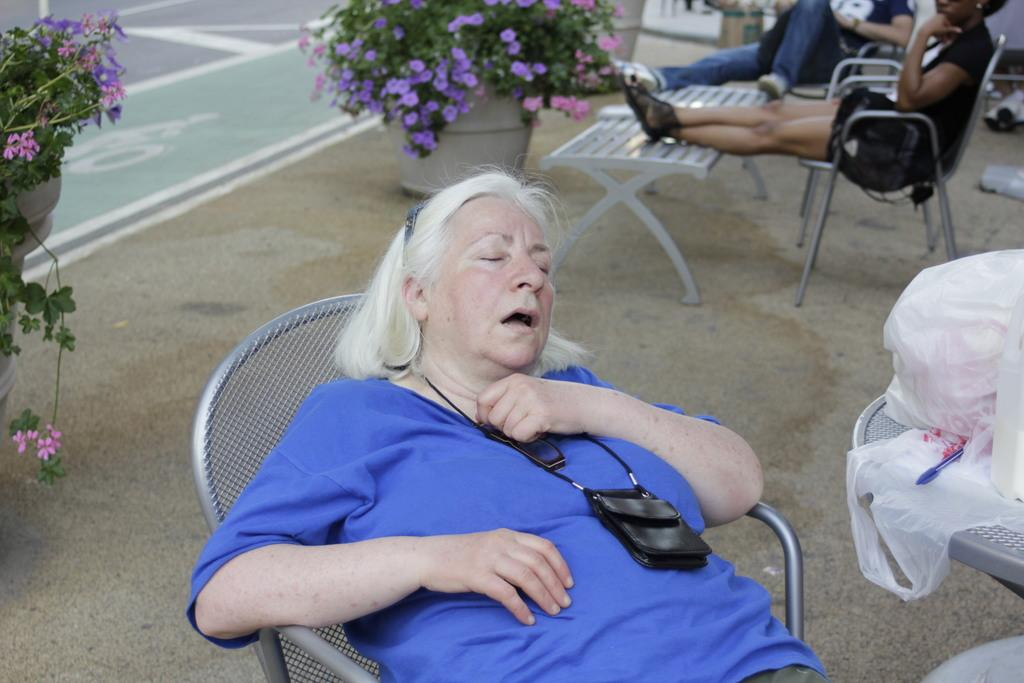Who is the main subject in the image? There is a woman in the image. What is the woman doing in the image? The woman is sitting on a chair and sleeping. Are there any other people in the image besides the woman? Yes, there are other people in the image. What else can be seen in the image besides the people? There are flowers in the image. What type of list is the woman holding in the image? There is no list present in the image; the woman is sleeping and not holding anything. 